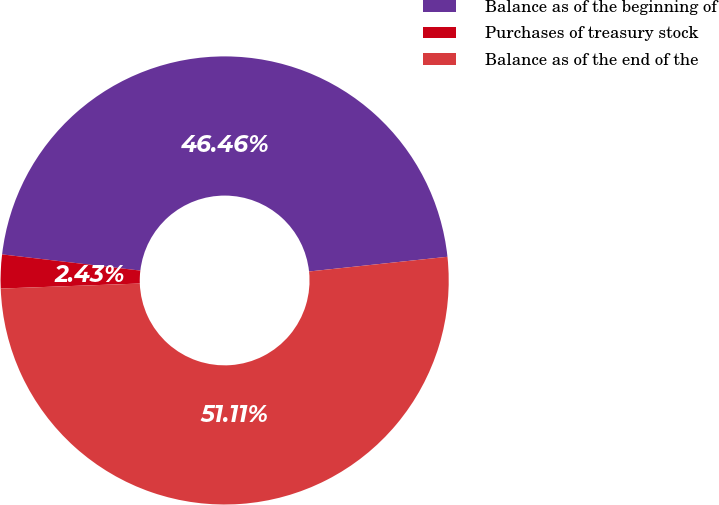<chart> <loc_0><loc_0><loc_500><loc_500><pie_chart><fcel>Balance as of the beginning of<fcel>Purchases of treasury stock<fcel>Balance as of the end of the<nl><fcel>46.46%<fcel>2.43%<fcel>51.11%<nl></chart> 